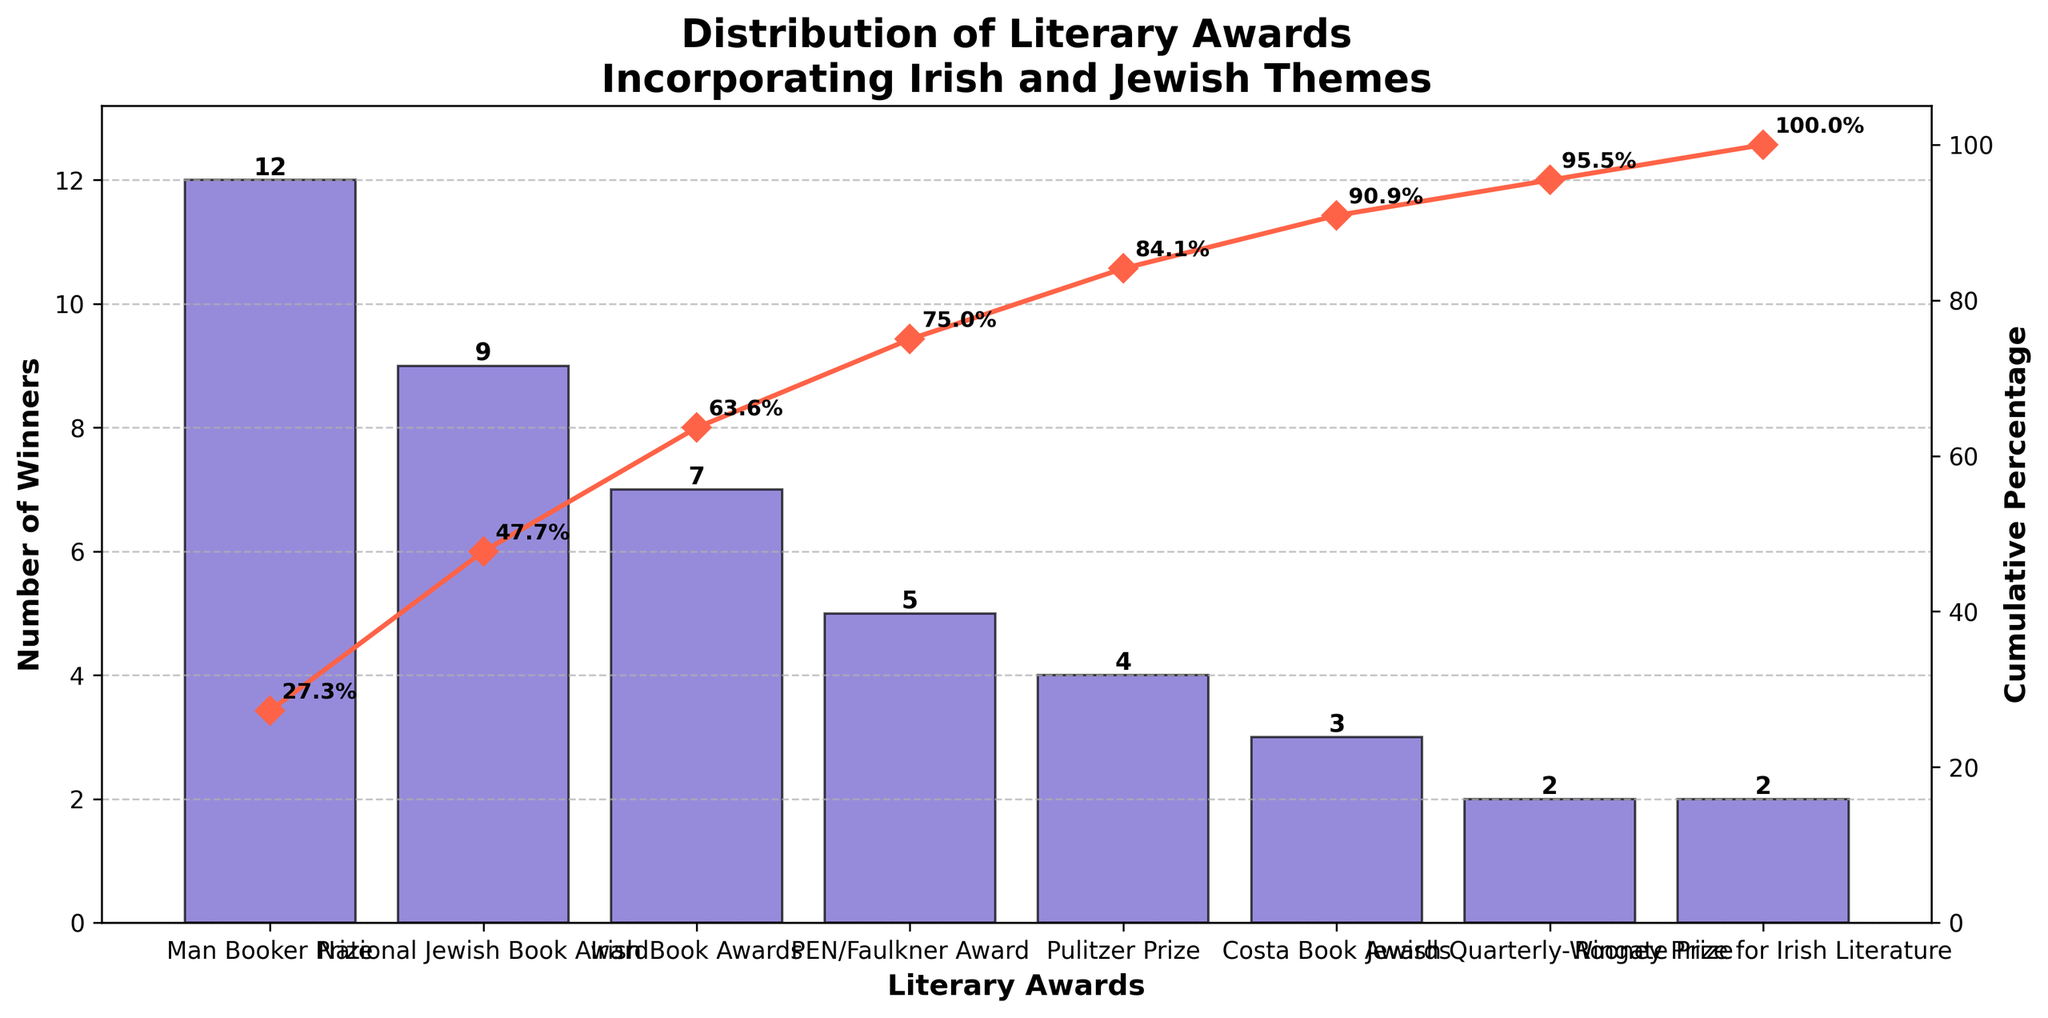What's the title of the figure? The title of the figure is displayed at the top and reads "Distribution of Literary Awards Incorporating Irish and Jewish Themes".
Answer: Distribution of Literary Awards Incorporating Irish and Jewish Themes How many awards are represented in the figure? By counting the number of bars and unique award labels on the x-axis, we see there are 8 different awards shown.
Answer: 8 Which award has the highest number of winners? The Man Booker Prize has the highest bar, indicating it has the most winners.
Answer: Man Booker Prize Which award has the lowest number of winners? Both the Jewish Quarterly-Wingate Prize and the Rooney Prize for Irish Literature have the shortest bars, indicating each has the fewest winners.
Answer: Jewish Quarterly-Wingate Prize and Rooney Prize for Irish Literature What is the cumulative percentage after the Man Booker Prize and the National Jewish Book Award? The cumulative percentage line reaches 49.4% after the National Jewish Book Award, which is the second bar from the left.
Answer: 49.4% What is the number of winners for the Costa Book Awards? The height of the Costa Book Awards bar is 3, which indicates the number of winners.
Answer: 3 How many awards have more than 5 winners? By visually comparing the bar heights, we see that the Man Booker Prize, National Jewish Book Award, and Irish Book Awards each have more than 5 winners.
Answer: 3 What's the combined number of winners for the PEN/Faulkner Award and the Pulitzer Prize? The PEN/Faulkner Award has 5 winners and the Pulitzer Prize has 4 winners. Adding these together, 5 + 4, gives a total of 9.
Answer: 9 What is the cumulative percentage after the top three awards? The cumulative percentage line reaches 70.5% after the Irish Book Awards, which is the third bar from the left.
Answer: 70.5% Comparing the Man Booker Prize and the Pulitzer Prize, how many more winners does the Man Booker Prize have? The Man Booker Prize has 12 winners, while the Pulitzer Prize has 4 winners. The difference is 12 - 4 = 8.
Answer: 8 